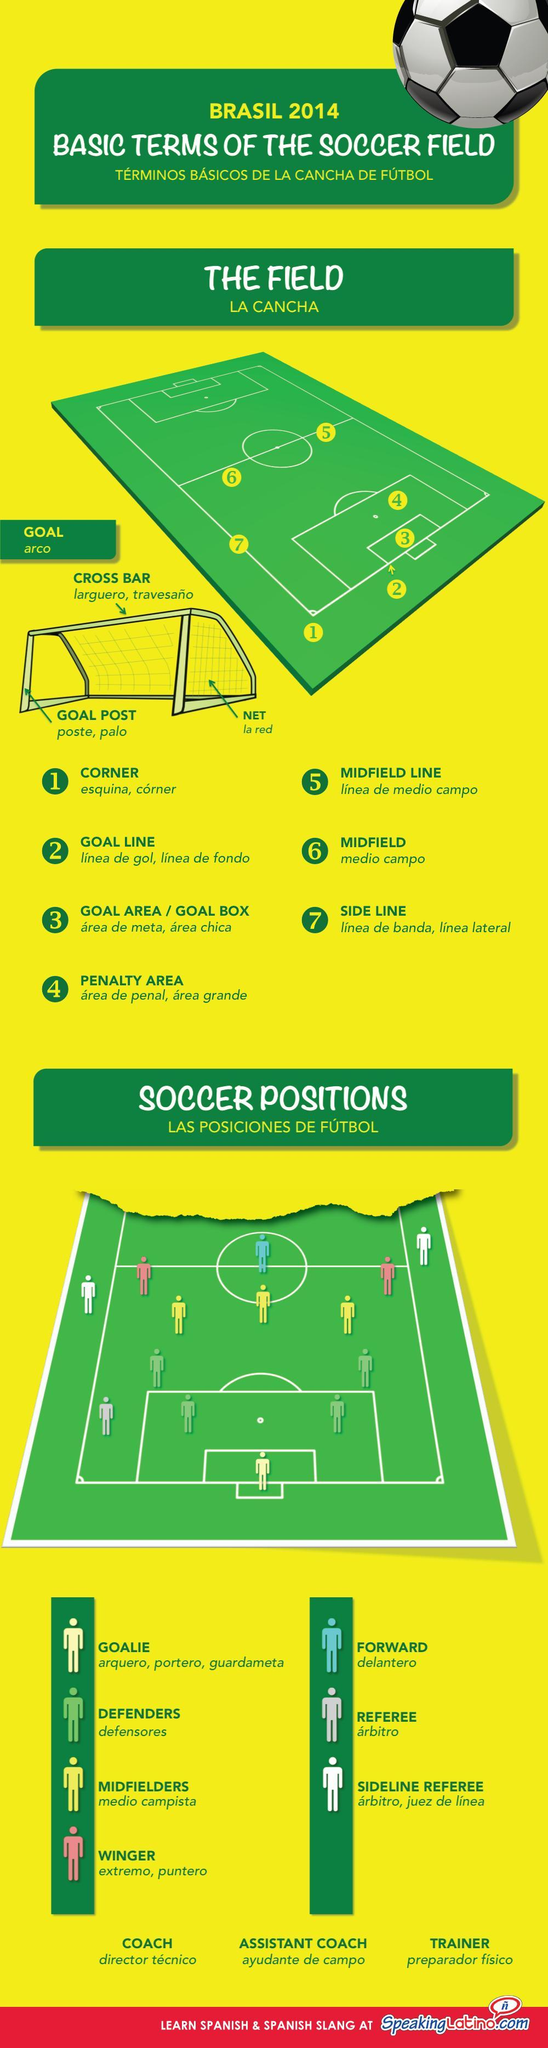WHat is the colour of then football field , green or yellow
Answer the question with a short phrase. green in which colour is the midfielder shown, pink or yellow yellow what do brasilians call the net la red what do brasilians call the field la cancha what is the top beam of the goal post called in English cross bar what do brazilian call the mid field medio campo In which colour is the wingers shown, pink or yellow pink 